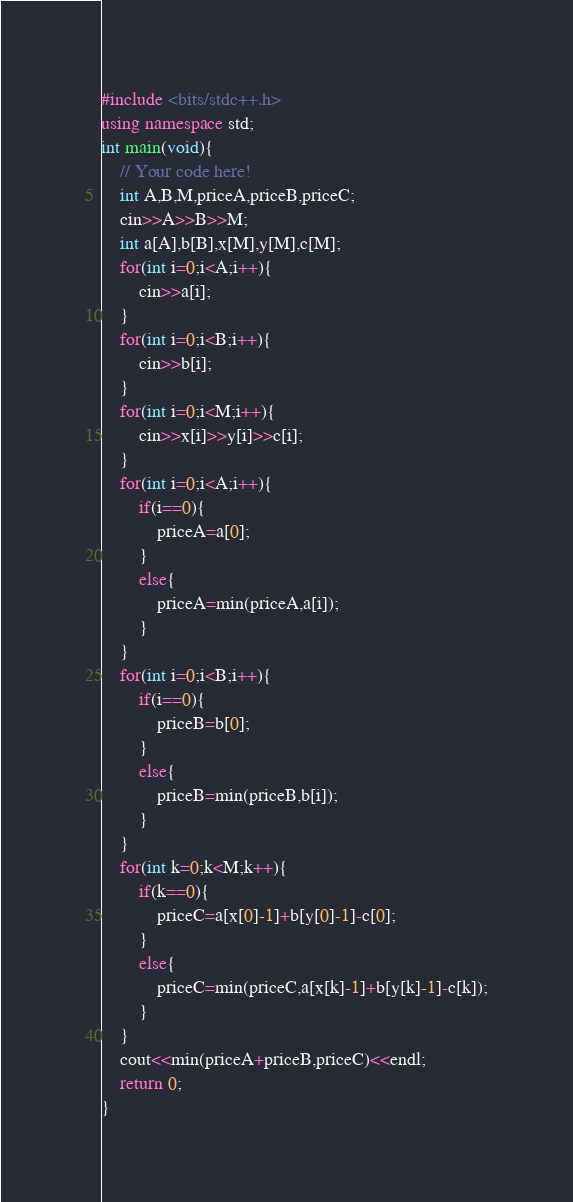<code> <loc_0><loc_0><loc_500><loc_500><_C++_>#include <bits/stdc++.h>
using namespace std;
int main(void){
    // Your code here!
    int A,B,M,priceA,priceB,priceC;
    cin>>A>>B>>M;
    int a[A],b[B],x[M],y[M],c[M];
    for(int i=0;i<A;i++){
        cin>>a[i];
    }
    for(int i=0;i<B;i++){
        cin>>b[i];
    }
    for(int i=0;i<M;i++){
        cin>>x[i]>>y[i]>>c[i];
    }
    for(int i=0;i<A;i++){
        if(i==0){
            priceA=a[0];
        }
        else{
            priceA=min(priceA,a[i]);
        }
    }
    for(int i=0;i<B;i++){
        if(i==0){
            priceB=b[0];
        }
        else{
            priceB=min(priceB,b[i]);
        }
    }
    for(int k=0;k<M;k++){
        if(k==0){
            priceC=a[x[0]-1]+b[y[0]-1]-c[0];
        }
        else{
            priceC=min(priceC,a[x[k]-1]+b[y[k]-1]-c[k]);
        }
    }
    cout<<min(priceA+priceB,priceC)<<endl;
    return 0;
}
</code> 